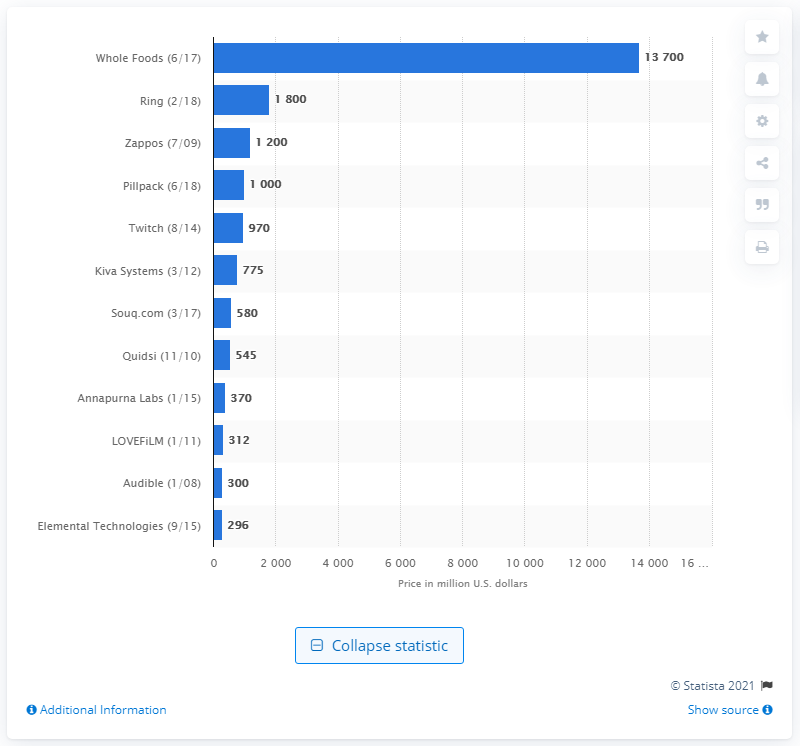Highlight a few significant elements in this photo. In August 2014, Amazon paid approximately $970 million for Twitch, a live streaming platform for gamers. 